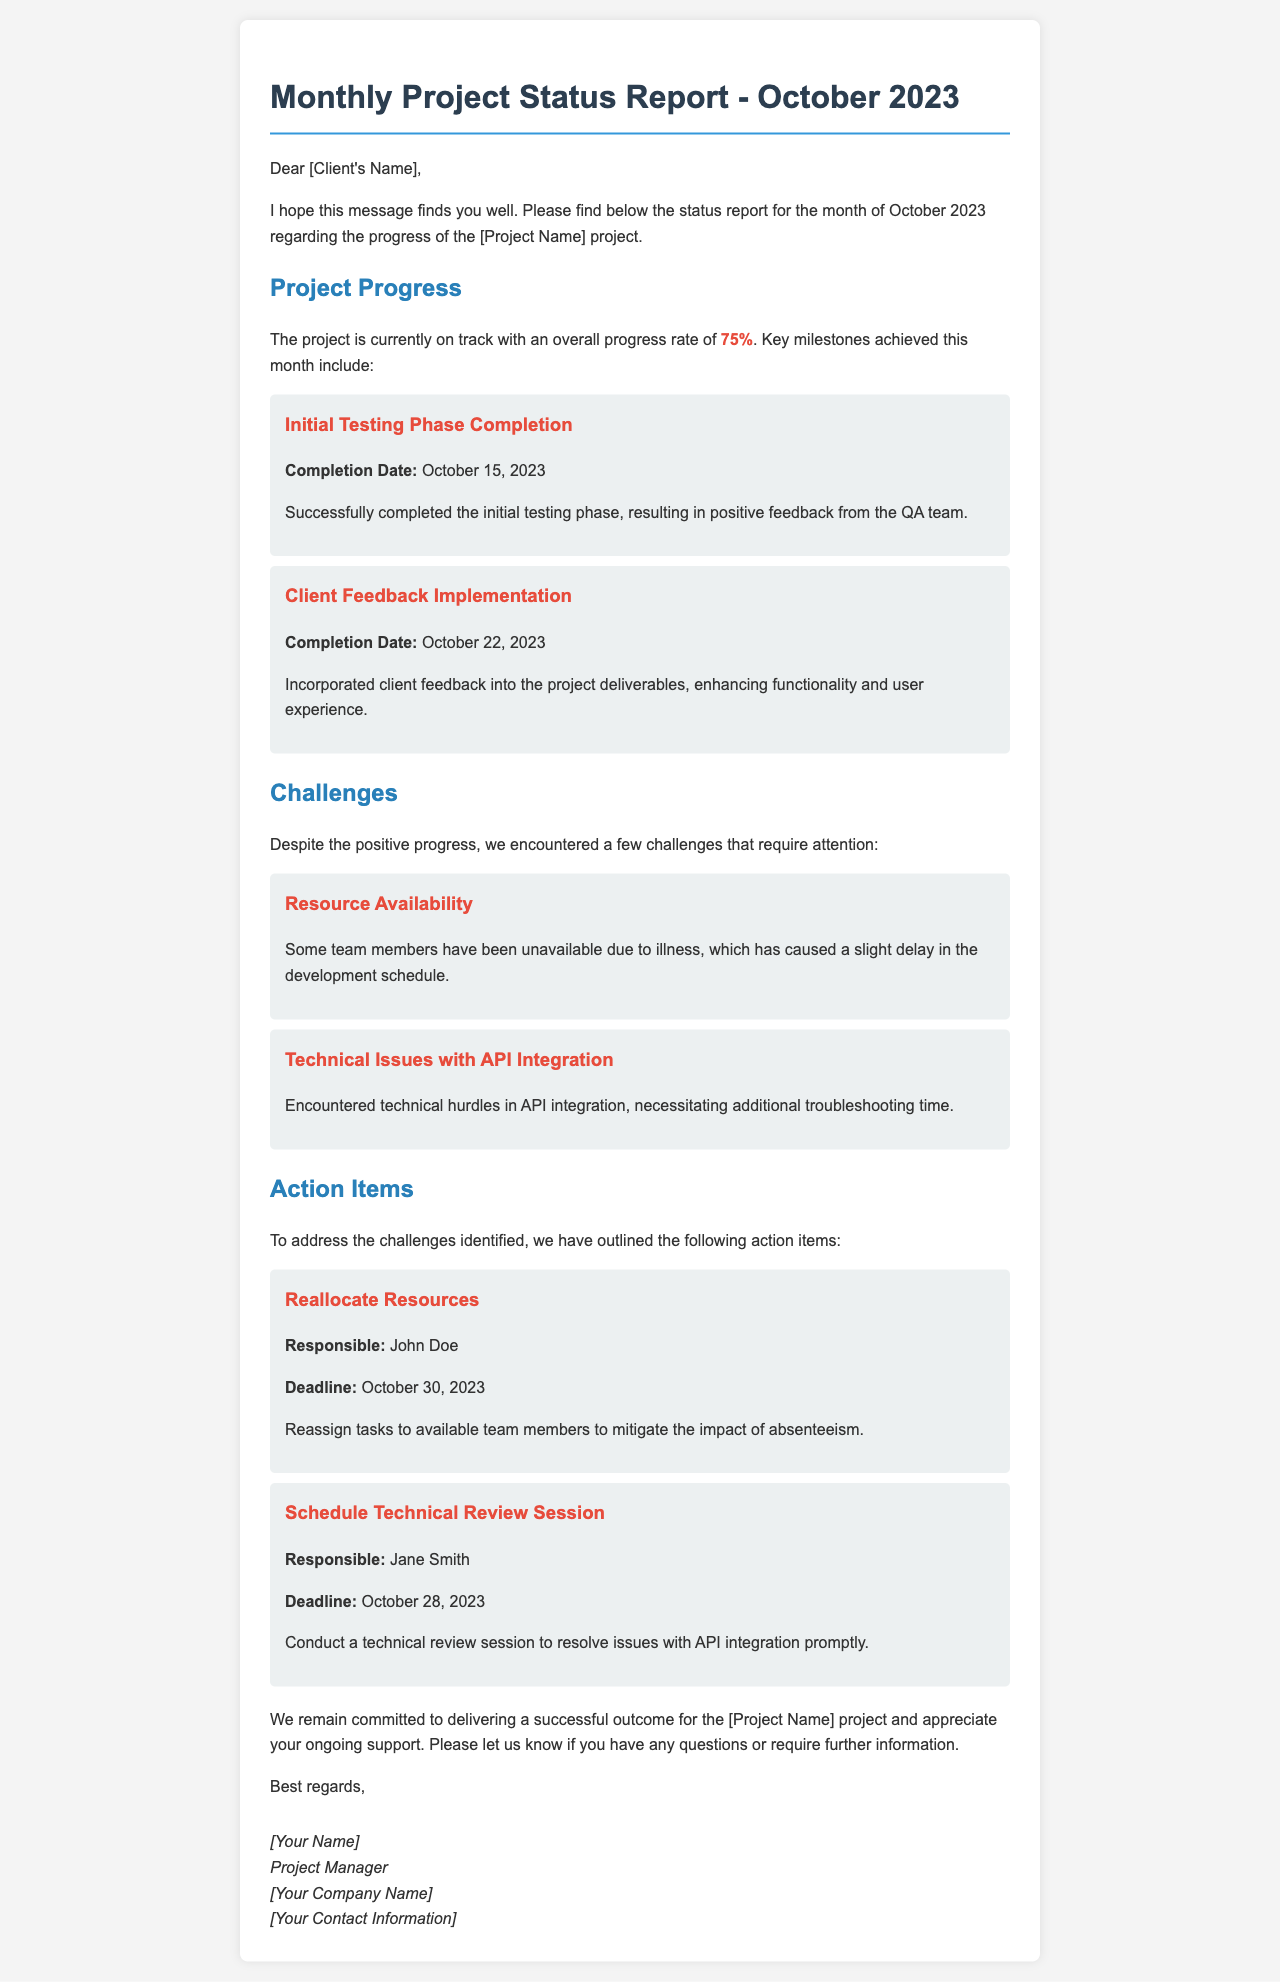what is the overall progress rate of the project? The overall progress rate is stated explicitly in the report as 75%.
Answer: 75% what is the completion date for the initial testing phase? The document specifies the completion date for the initial testing phase as October 15, 2023.
Answer: October 15, 2023 who is responsible for reallocating resources? The document mentions that John Doe is responsible for reallocating resources.
Answer: John Doe what challenge is related to team member availability? The report discusses the challenge of resource availability due to some team members being unavailable.
Answer: Resource Availability how many milestones were mentioned in the project progress section? The milestones section lists two achievements in the project progress, namely the initial testing phase completion and client feedback implementation.
Answer: 2 what is the deadline for the technical review session? The deadline for the technical review session, as stated in the action items, is October 28, 2023.
Answer: October 28, 2023 which issue requires additional troubleshooting time? The technical issue described is related to API integration and requires additional troubleshooting time.
Answer: Technical Issues with API Integration what is the purpose of the monthly project status report? The purpose of the report is to provide an update on the progress, challenges, and action items of the project to the client.
Answer: Status update 